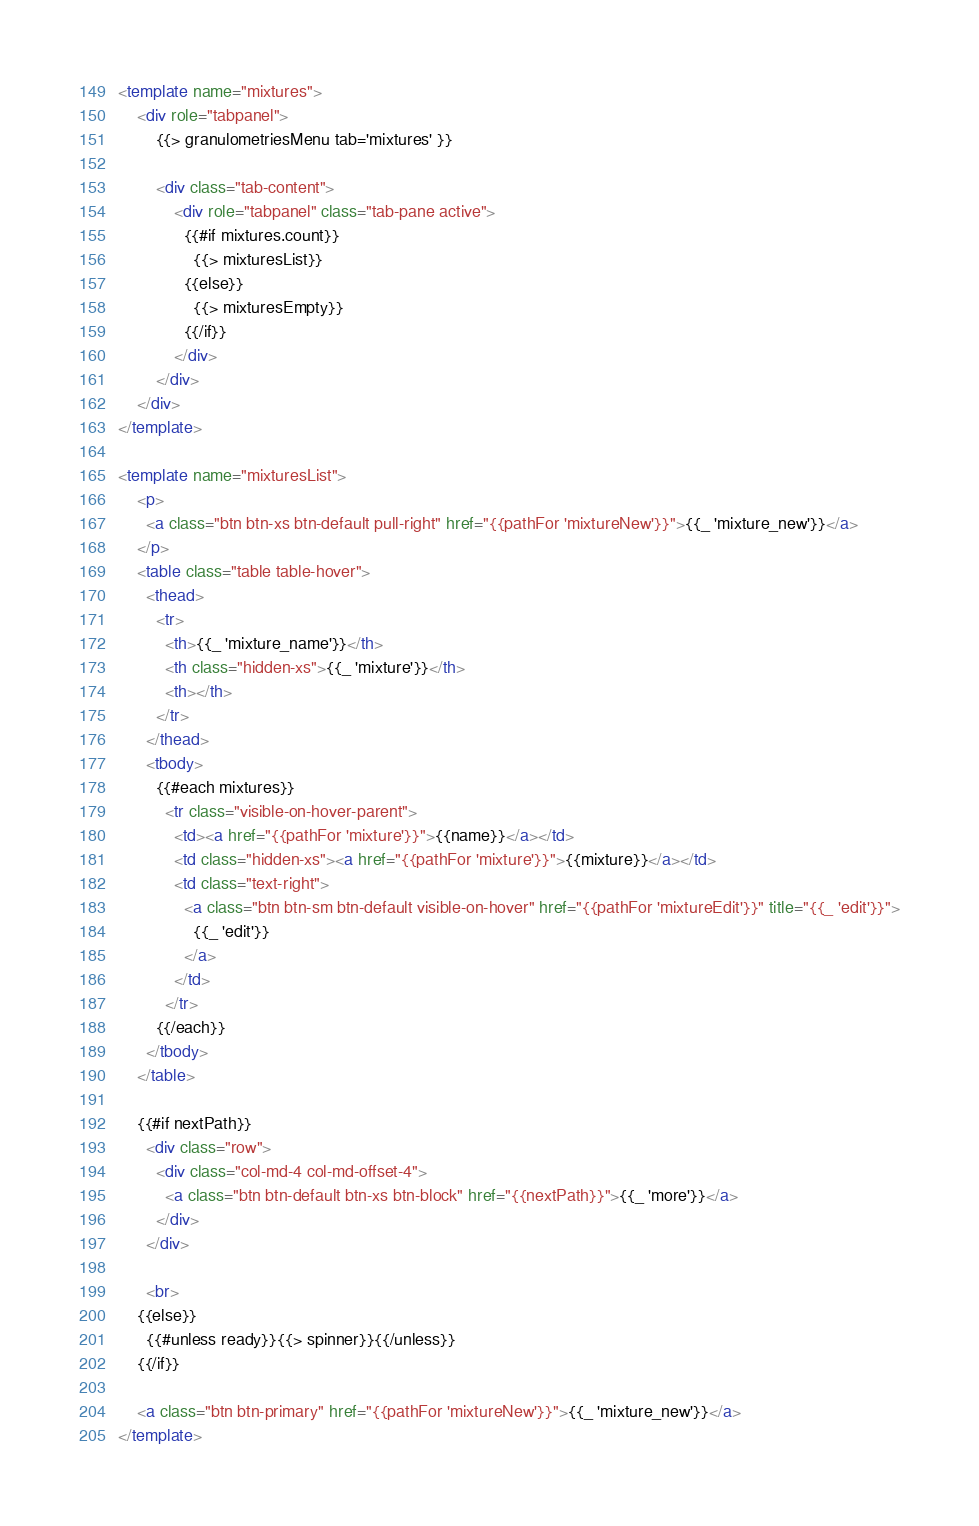Convert code to text. <code><loc_0><loc_0><loc_500><loc_500><_HTML_><template name="mixtures">
    <div role="tabpanel">
        {{> granulometriesMenu tab='mixtures' }}

        <div class="tab-content">
            <div role="tabpanel" class="tab-pane active">
              {{#if mixtures.count}}
                {{> mixturesList}}
              {{else}}
                {{> mixturesEmpty}}
              {{/if}}
            </div>
        </div>
    </div>
</template>

<template name="mixturesList">
    <p>
      <a class="btn btn-xs btn-default pull-right" href="{{pathFor 'mixtureNew'}}">{{_ 'mixture_new'}}</a>
    </p>
    <table class="table table-hover">
      <thead>
        <tr>
          <th>{{_ 'mixture_name'}}</th>
          <th class="hidden-xs">{{_ 'mixture'}}</th>
          <th></th>
        </tr>
      </thead>
      <tbody>
        {{#each mixtures}}
          <tr class="visible-on-hover-parent">
            <td><a href="{{pathFor 'mixture'}}">{{name}}</a></td>
            <td class="hidden-xs"><a href="{{pathFor 'mixture'}}">{{mixture}}</a></td>
            <td class="text-right">
              <a class="btn btn-sm btn-default visible-on-hover" href="{{pathFor 'mixtureEdit'}}" title="{{_ 'edit'}}">
                {{_ 'edit'}}
              </a>
            </td>
          </tr>
        {{/each}}
      </tbody>
    </table>

    {{#if nextPath}}
      <div class="row">
        <div class="col-md-4 col-md-offset-4">
          <a class="btn btn-default btn-xs btn-block" href="{{nextPath}}">{{_ 'more'}}</a>
        </div>
      </div>

      <br>
    {{else}}
      {{#unless ready}}{{> spinner}}{{/unless}}
    {{/if}}

    <a class="btn btn-primary" href="{{pathFor 'mixtureNew'}}">{{_ 'mixture_new'}}</a>
</template>
</code> 